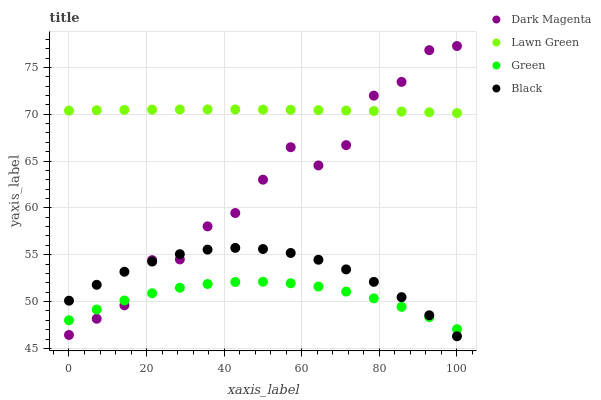Does Green have the minimum area under the curve?
Answer yes or no. Yes. Does Lawn Green have the maximum area under the curve?
Answer yes or no. Yes. Does Dark Magenta have the minimum area under the curve?
Answer yes or no. No. Does Dark Magenta have the maximum area under the curve?
Answer yes or no. No. Is Lawn Green the smoothest?
Answer yes or no. Yes. Is Dark Magenta the roughest?
Answer yes or no. Yes. Is Green the smoothest?
Answer yes or no. No. Is Green the roughest?
Answer yes or no. No. Does Black have the lowest value?
Answer yes or no. Yes. Does Green have the lowest value?
Answer yes or no. No. Does Dark Magenta have the highest value?
Answer yes or no. Yes. Does Green have the highest value?
Answer yes or no. No. Is Green less than Lawn Green?
Answer yes or no. Yes. Is Lawn Green greater than Green?
Answer yes or no. Yes. Does Green intersect Dark Magenta?
Answer yes or no. Yes. Is Green less than Dark Magenta?
Answer yes or no. No. Is Green greater than Dark Magenta?
Answer yes or no. No. Does Green intersect Lawn Green?
Answer yes or no. No. 